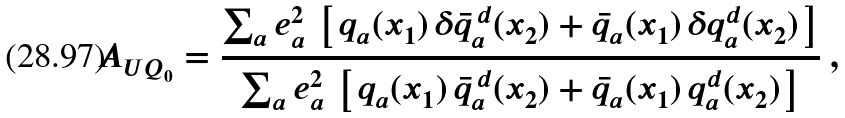Convert formula to latex. <formula><loc_0><loc_0><loc_500><loc_500>A _ { U Q _ { 0 } } = \frac { \sum _ { a } e _ { a } ^ { 2 } \, \left [ \, q _ { a } ( x _ { 1 } ) \, \delta \bar { q } _ { a } ^ { \, d } ( x _ { 2 } ) + \bar { q } _ { a } ( x _ { 1 } ) \, \delta q _ { a } ^ { d } ( x _ { 2 } ) \, \right ] } { \sum _ { a } e _ { a } ^ { 2 } \, \left [ \, q _ { a } ( x _ { 1 } ) \, \bar { q } _ { a } ^ { \, d } ( x _ { 2 } ) + \bar { q } _ { a } ( x _ { 1 } ) \, q _ { a } ^ { d } ( x _ { 2 } ) \, \right ] } \ ,</formula> 